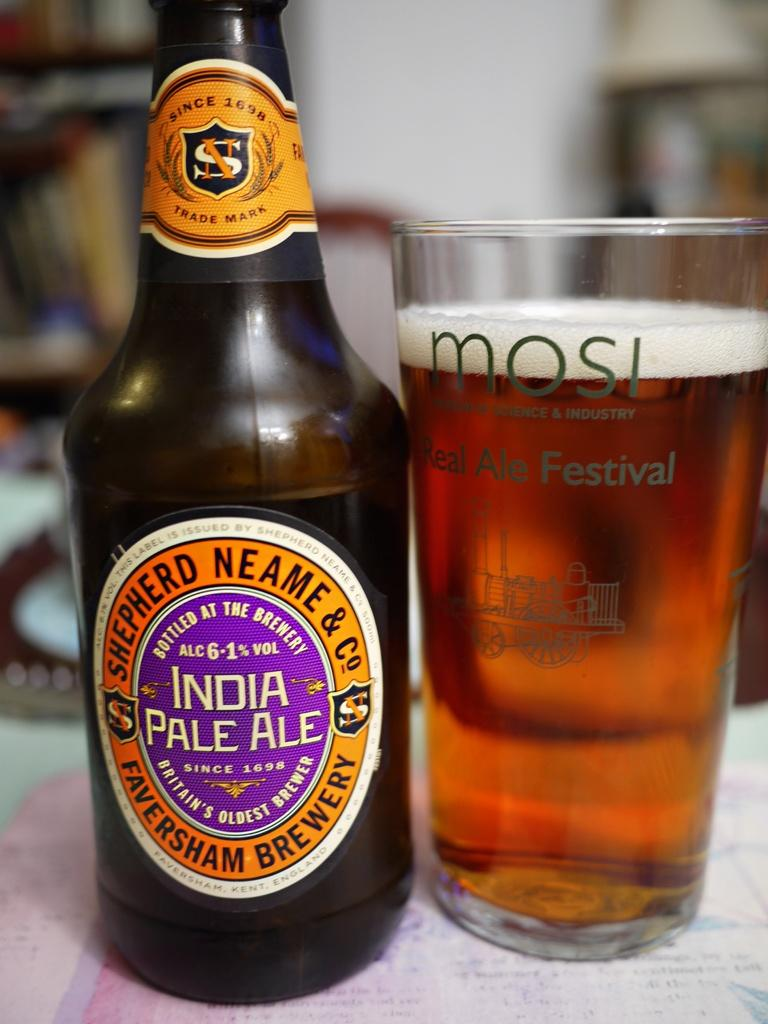Provide a one-sentence caption for the provided image. India Pale ale with a glass of beer on the side of the bottle. 